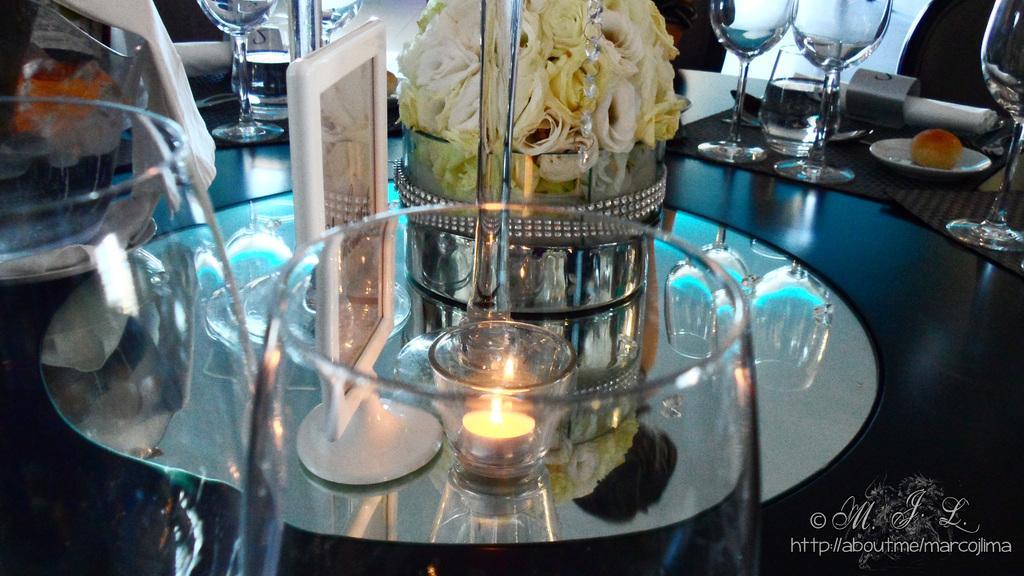Can you describe this image briefly? In this Image I see glasses, a candle over here and few flowers. 